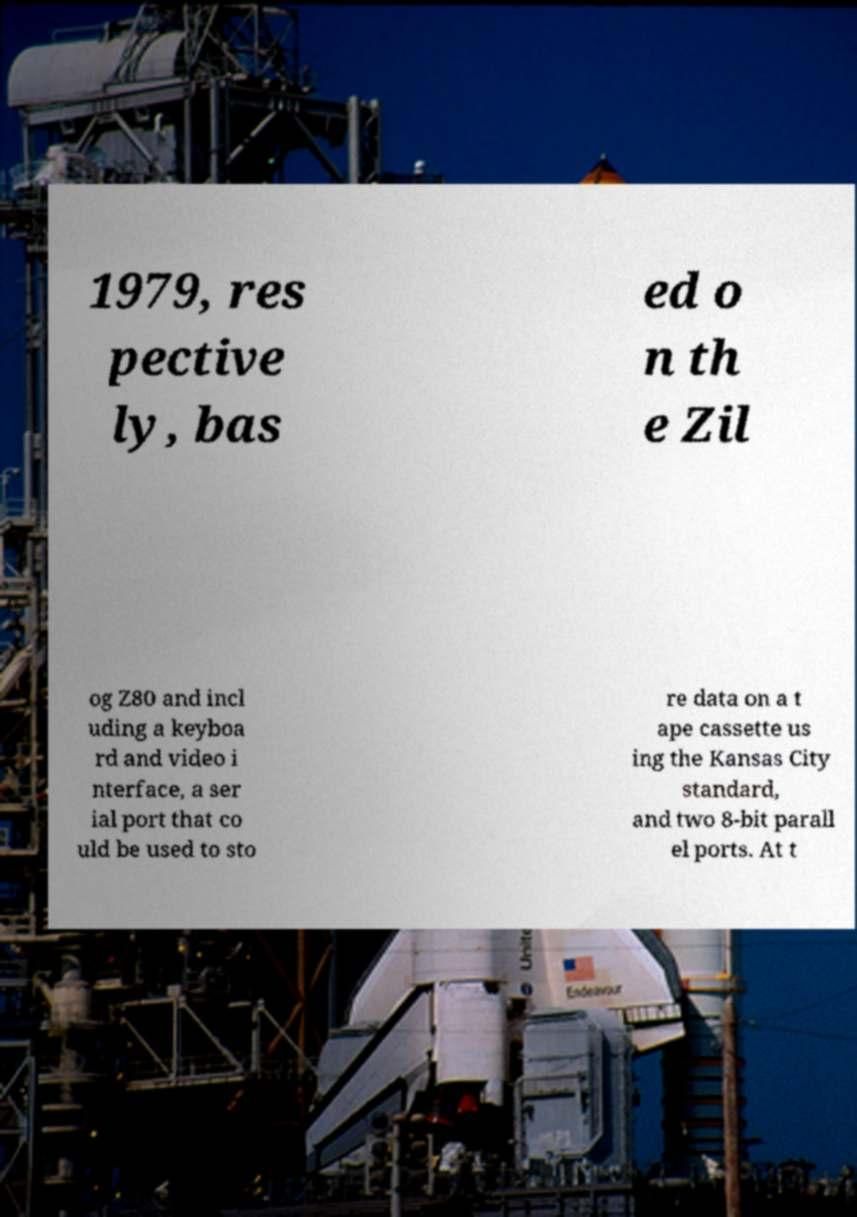There's text embedded in this image that I need extracted. Can you transcribe it verbatim? 1979, res pective ly, bas ed o n th e Zil og Z80 and incl uding a keyboa rd and video i nterface, a ser ial port that co uld be used to sto re data on a t ape cassette us ing the Kansas City standard, and two 8-bit parall el ports. At t 